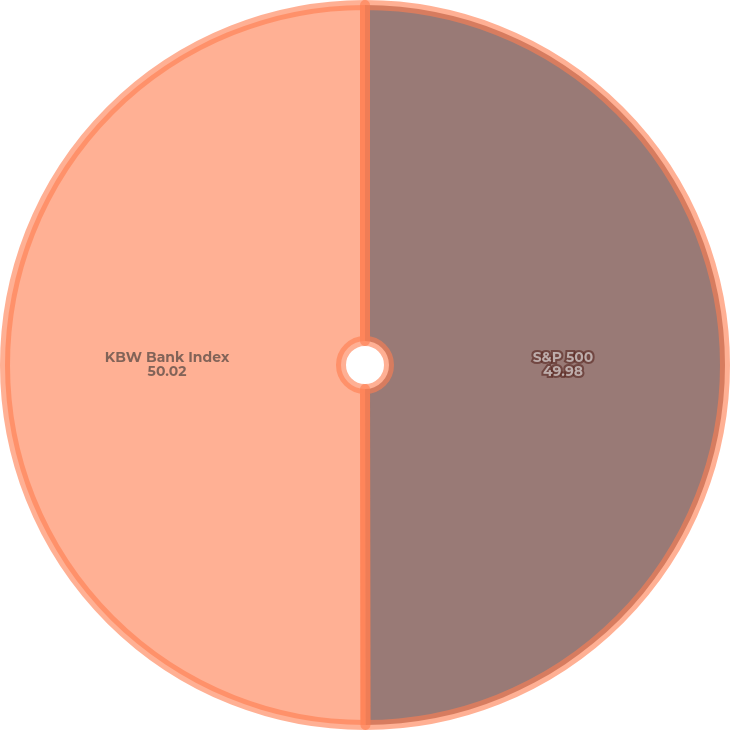Convert chart to OTSL. <chart><loc_0><loc_0><loc_500><loc_500><pie_chart><fcel>S&P 500<fcel>KBW Bank Index<nl><fcel>49.98%<fcel>50.02%<nl></chart> 